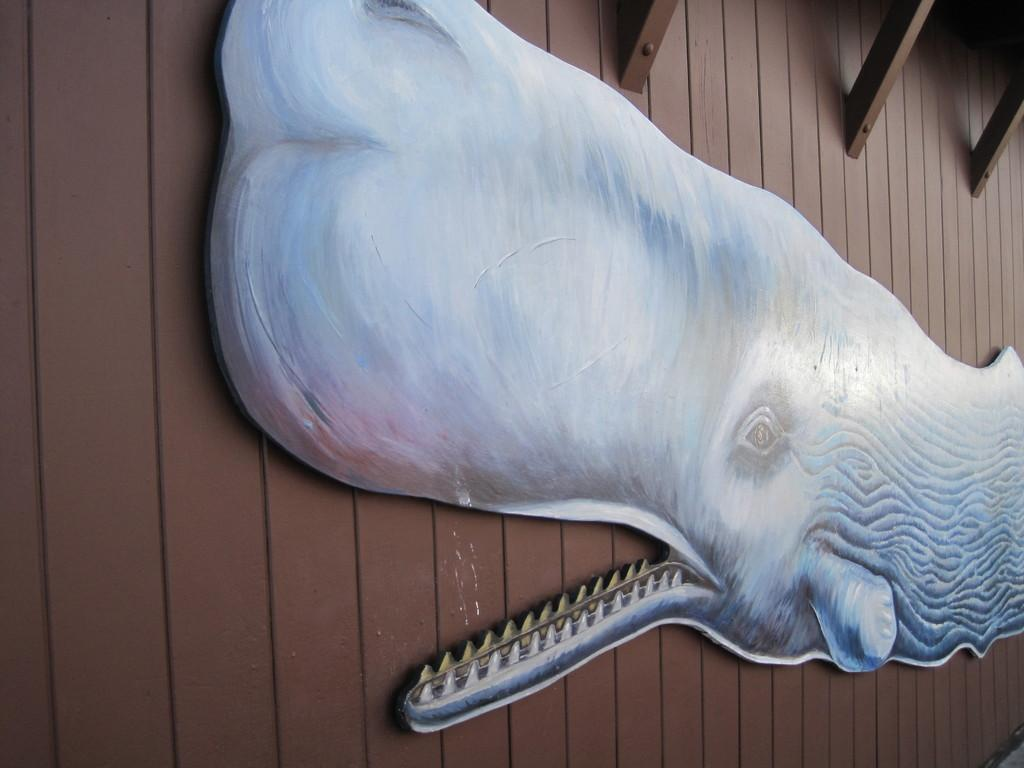What is the main subject of the image? There is an art piece in the image. What does the art piece resemble? The art piece resembles a whale. What is the art piece attached to? The art piece is attached to a wooden surface. How many boats are present in the image? There are no boats present in the image; it features an art piece resembling a whale attached to a wooden surface. What type of arithmetic problem can be solved using the art piece? The art piece does not involve any arithmetic problems; it is a visual representation of a whale. 